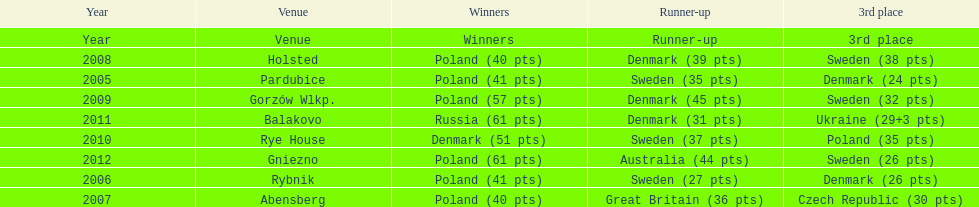When was the first year that poland did not place in the top three positions of the team speedway junior world championship? 2011. 